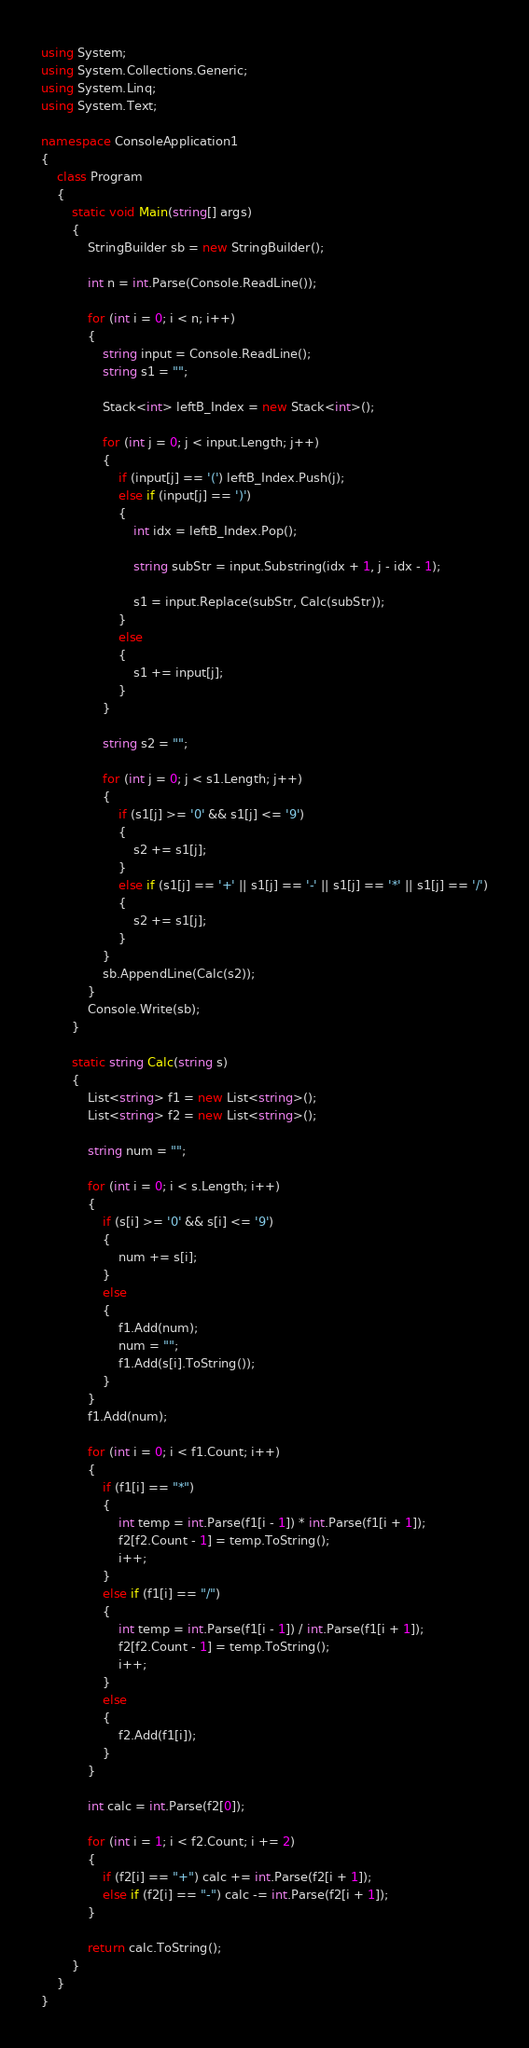Convert code to text. <code><loc_0><loc_0><loc_500><loc_500><_C#_>using System;
using System.Collections.Generic;
using System.Linq;
using System.Text;

namespace ConsoleApplication1
{
    class Program
    {
        static void Main(string[] args)
        {
            StringBuilder sb = new StringBuilder();

            int n = int.Parse(Console.ReadLine());

            for (int i = 0; i < n; i++)
            {
                string input = Console.ReadLine();
                string s1 = "";

                Stack<int> leftB_Index = new Stack<int>();

                for (int j = 0; j < input.Length; j++)
                {
                    if (input[j] == '(') leftB_Index.Push(j);
                    else if (input[j] == ')')
                    {
                        int idx = leftB_Index.Pop();

                        string subStr = input.Substring(idx + 1, j - idx - 1);

                        s1 = input.Replace(subStr, Calc(subStr));
                    }
                    else
                    {
                        s1 += input[j];
                    }
                }

                string s2 = "";

                for (int j = 0; j < s1.Length; j++)
                {
                    if (s1[j] >= '0' && s1[j] <= '9')
                    {
                        s2 += s1[j];
                    }
                    else if (s1[j] == '+' || s1[j] == '-' || s1[j] == '*' || s1[j] == '/')
                    {
                        s2 += s1[j];
                    }
                }
                sb.AppendLine(Calc(s2));
            }
            Console.Write(sb);
        }

        static string Calc(string s)
        {
            List<string> f1 = new List<string>();
            List<string> f2 = new List<string>();

            string num = "";

            for (int i = 0; i < s.Length; i++)
            {
                if (s[i] >= '0' && s[i] <= '9')
                {
                    num += s[i];
                }
                else
                {
                    f1.Add(num);
                    num = "";
                    f1.Add(s[i].ToString());
                }
            }
            f1.Add(num);

            for (int i = 0; i < f1.Count; i++)
            {
                if (f1[i] == "*")
                {
                    int temp = int.Parse(f1[i - 1]) * int.Parse(f1[i + 1]);
                    f2[f2.Count - 1] = temp.ToString();
                    i++;
                }
                else if (f1[i] == "/")
                {
                    int temp = int.Parse(f1[i - 1]) / int.Parse(f1[i + 1]);
                    f2[f2.Count - 1] = temp.ToString();
                    i++;
                }
                else
                {
                    f2.Add(f1[i]);
                }
            }

            int calc = int.Parse(f2[0]);

            for (int i = 1; i < f2.Count; i += 2)
            {
                if (f2[i] == "+") calc += int.Parse(f2[i + 1]);
                else if (f2[i] == "-") calc -= int.Parse(f2[i + 1]);
            }

            return calc.ToString();
        }
    }
}</code> 